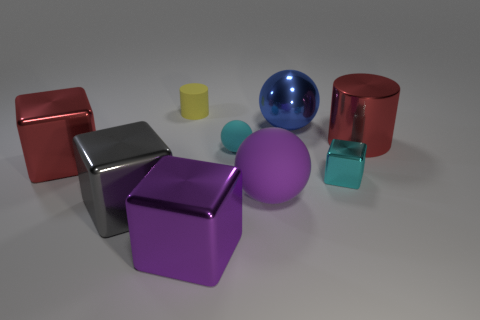Add 1 large spheres. How many objects exist? 10 Subtract all balls. How many objects are left? 6 Subtract all purple metallic cylinders. Subtract all tiny cyan shiny cubes. How many objects are left? 8 Add 9 big metallic cylinders. How many big metallic cylinders are left? 10 Add 6 big gray metal objects. How many big gray metal objects exist? 7 Subtract 0 gray cylinders. How many objects are left? 9 